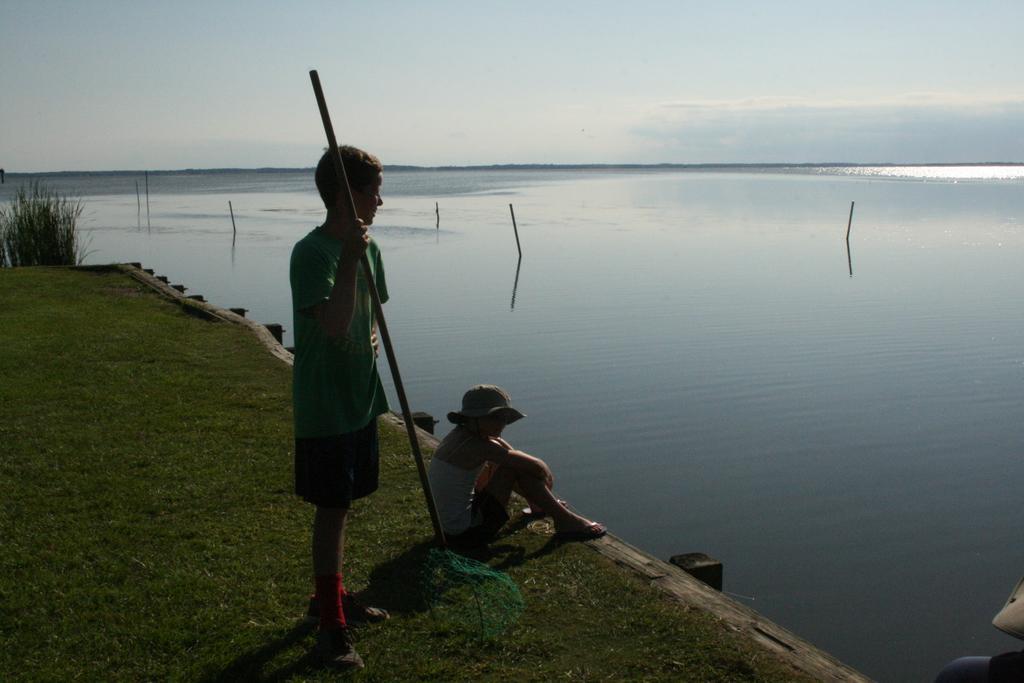Could you give a brief overview of what you see in this image? In this image I can see the lake, on which I can see some poles, in front of the lake I can see grass and poles, children's and one boy holding a stick and standing on the ground ,at the top there is the sky. 